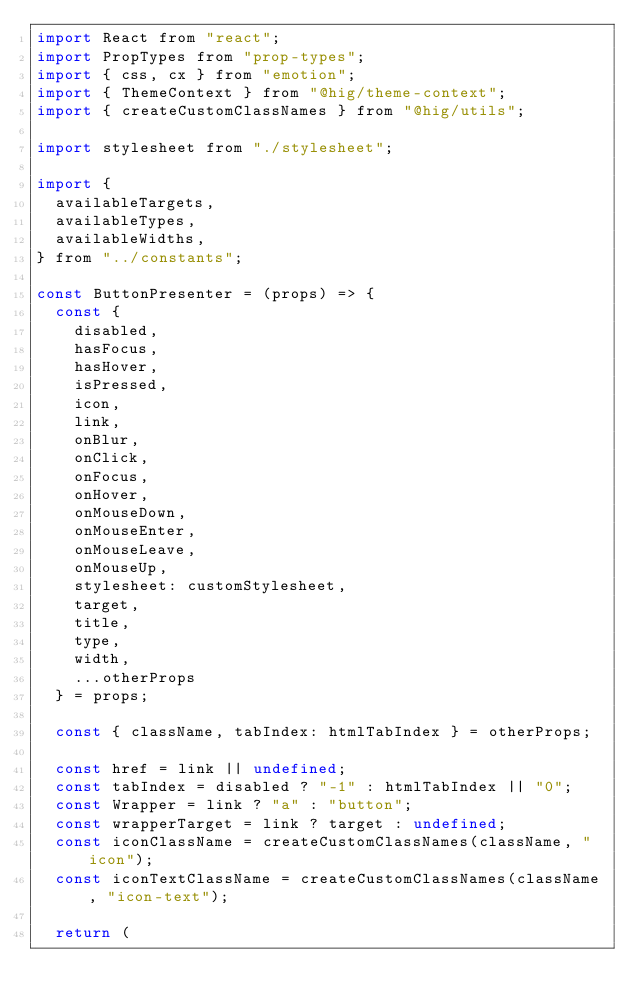Convert code to text. <code><loc_0><loc_0><loc_500><loc_500><_JavaScript_>import React from "react";
import PropTypes from "prop-types";
import { css, cx } from "emotion";
import { ThemeContext } from "@hig/theme-context";
import { createCustomClassNames } from "@hig/utils";

import stylesheet from "./stylesheet";

import {
  availableTargets,
  availableTypes,
  availableWidths,
} from "../constants";

const ButtonPresenter = (props) => {
  const {
    disabled,
    hasFocus,
    hasHover,
    isPressed,
    icon,
    link,
    onBlur,
    onClick,
    onFocus,
    onHover,
    onMouseDown,
    onMouseEnter,
    onMouseLeave,
    onMouseUp,
    stylesheet: customStylesheet,
    target,
    title,
    type,
    width,
    ...otherProps
  } = props;

  const { className, tabIndex: htmlTabIndex } = otherProps;

  const href = link || undefined;
  const tabIndex = disabled ? "-1" : htmlTabIndex || "0";
  const Wrapper = link ? "a" : "button";
  const wrapperTarget = link ? target : undefined;
  const iconClassName = createCustomClassNames(className, "icon");
  const iconTextClassName = createCustomClassNames(className, "icon-text");

  return (</code> 